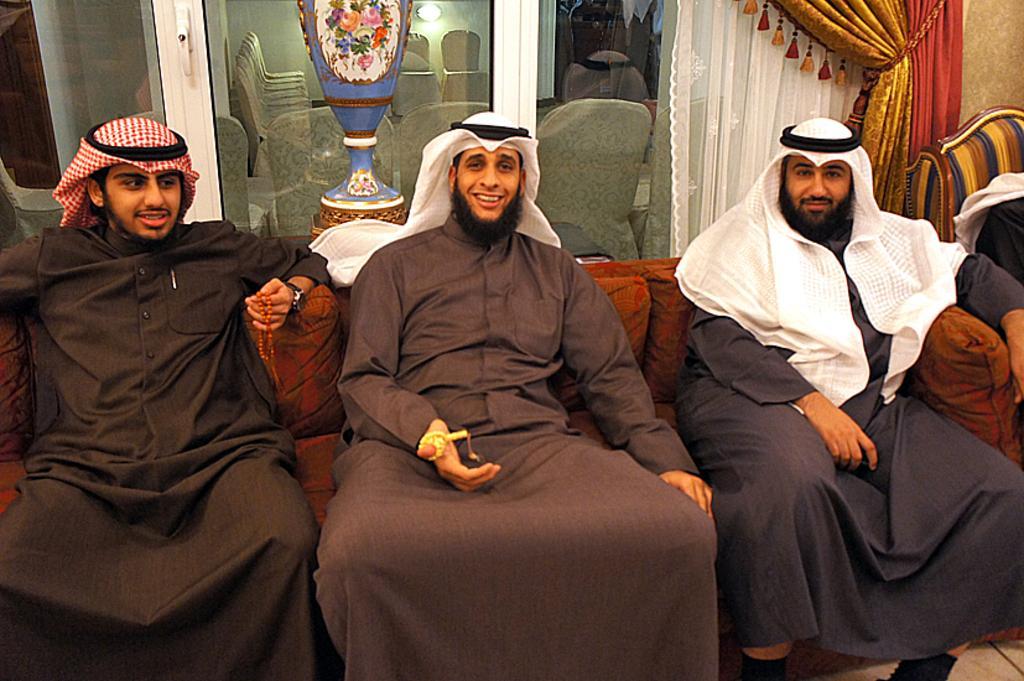Describe this image in one or two sentences. In this image there are three persons seated on chairs with a smile on their face, behind them there is a glass door inside the glass door there are chairs. 